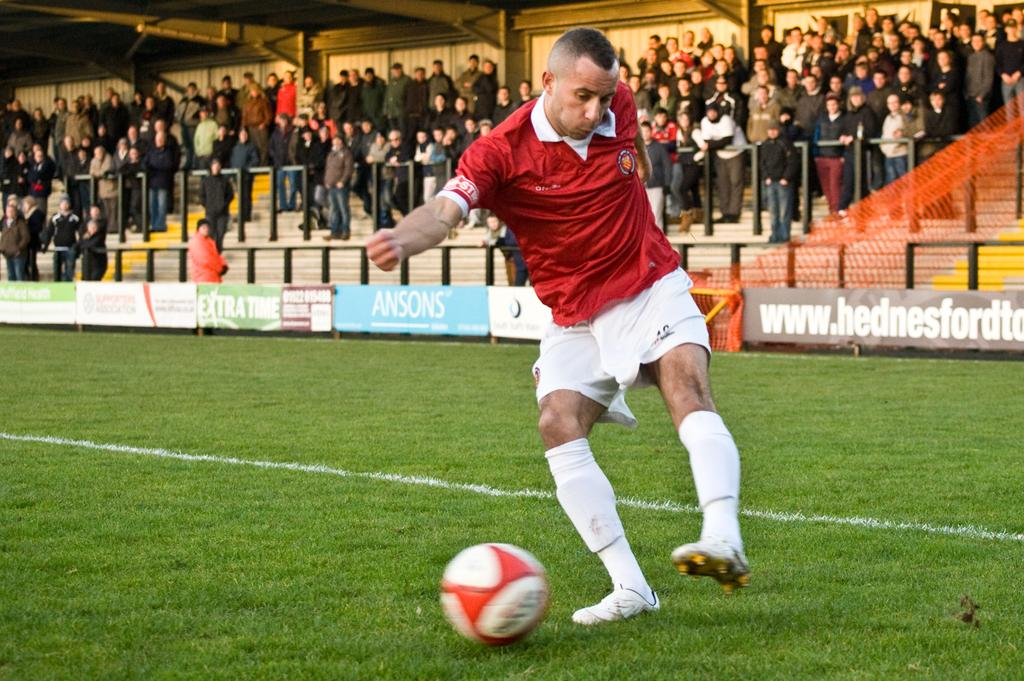<image>
Give a short and clear explanation of the subsequent image. A player in red dribbles a soccer ball near a blue banner sponsored by ANSONS. 